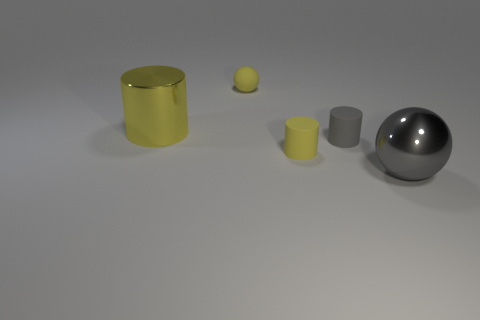What is the color of the large object that is left of the yellow object behind the large yellow metal cylinder?
Keep it short and to the point. Yellow. Is the number of big metal cylinders that are behind the big yellow thing less than the number of big gray things to the left of the small gray matte cylinder?
Your response must be concise. No. Does the yellow ball have the same size as the shiny object behind the big gray ball?
Make the answer very short. No. There is a object that is in front of the gray rubber cylinder and behind the gray metal thing; what shape is it?
Keep it short and to the point. Cylinder. The other cylinder that is made of the same material as the tiny gray cylinder is what size?
Your answer should be compact. Small. What number of tiny gray matte cylinders are to the right of the big thing behind the big gray shiny object?
Offer a very short reply. 1. Is the large object that is left of the big gray sphere made of the same material as the tiny sphere?
Your response must be concise. No. Is there any other thing that is the same material as the small gray cylinder?
Your response must be concise. Yes. What size is the metal thing that is in front of the yellow cylinder that is to the left of the yellow rubber cylinder?
Make the answer very short. Large. How big is the yellow metallic object that is on the left side of the metal thing that is in front of the big thing on the left side of the big ball?
Provide a succinct answer. Large. 